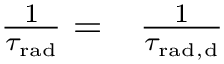<formula> <loc_0><loc_0><loc_500><loc_500>\begin{array} { r l } { \frac { 1 } { \tau _ { r a d } } = } & \frac { 1 } { \tau _ { { r a d } , { d } } } } \end{array}</formula> 